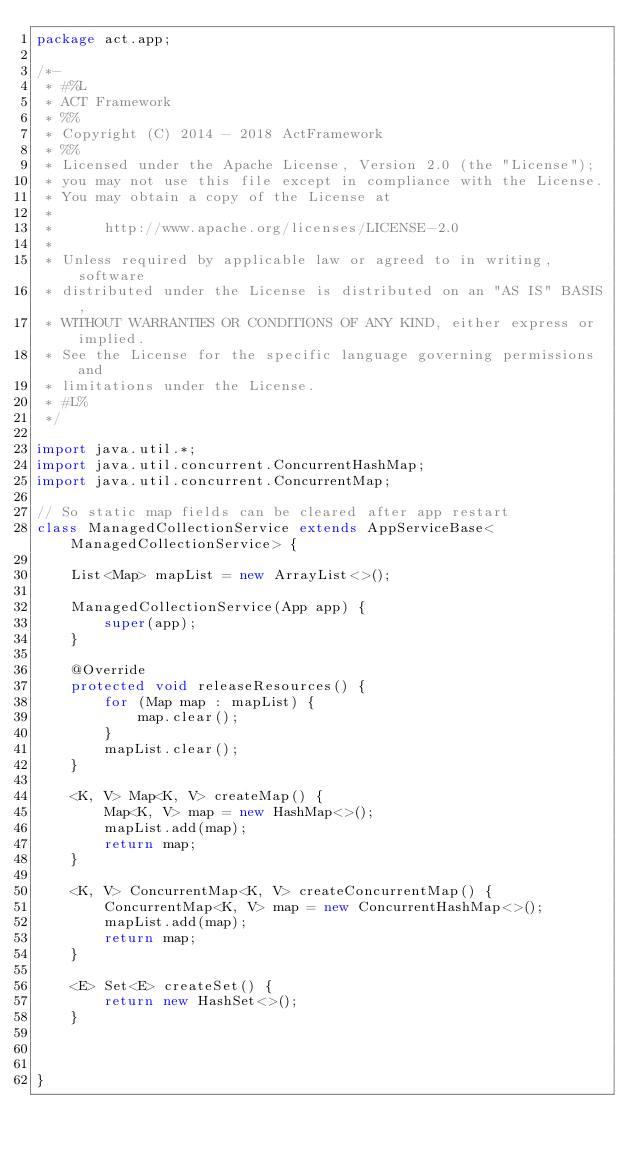Convert code to text. <code><loc_0><loc_0><loc_500><loc_500><_Java_>package act.app;

/*-
 * #%L
 * ACT Framework
 * %%
 * Copyright (C) 2014 - 2018 ActFramework
 * %%
 * Licensed under the Apache License, Version 2.0 (the "License");
 * you may not use this file except in compliance with the License.
 * You may obtain a copy of the License at
 * 
 *      http://www.apache.org/licenses/LICENSE-2.0
 * 
 * Unless required by applicable law or agreed to in writing, software
 * distributed under the License is distributed on an "AS IS" BASIS,
 * WITHOUT WARRANTIES OR CONDITIONS OF ANY KIND, either express or implied.
 * See the License for the specific language governing permissions and
 * limitations under the License.
 * #L%
 */

import java.util.*;
import java.util.concurrent.ConcurrentHashMap;
import java.util.concurrent.ConcurrentMap;

// So static map fields can be cleared after app restart
class ManagedCollectionService extends AppServiceBase<ManagedCollectionService> {

    List<Map> mapList = new ArrayList<>();

    ManagedCollectionService(App app) {
        super(app);
    }

    @Override
    protected void releaseResources() {
        for (Map map : mapList) {
            map.clear();
        }
        mapList.clear();
    }

    <K, V> Map<K, V> createMap() {
        Map<K, V> map = new HashMap<>();
        mapList.add(map);
        return map;
    }

    <K, V> ConcurrentMap<K, V> createConcurrentMap() {
        ConcurrentMap<K, V> map = new ConcurrentHashMap<>();
        mapList.add(map);
        return map;
    }

    <E> Set<E> createSet() {
        return new HashSet<>();
    }



}
</code> 